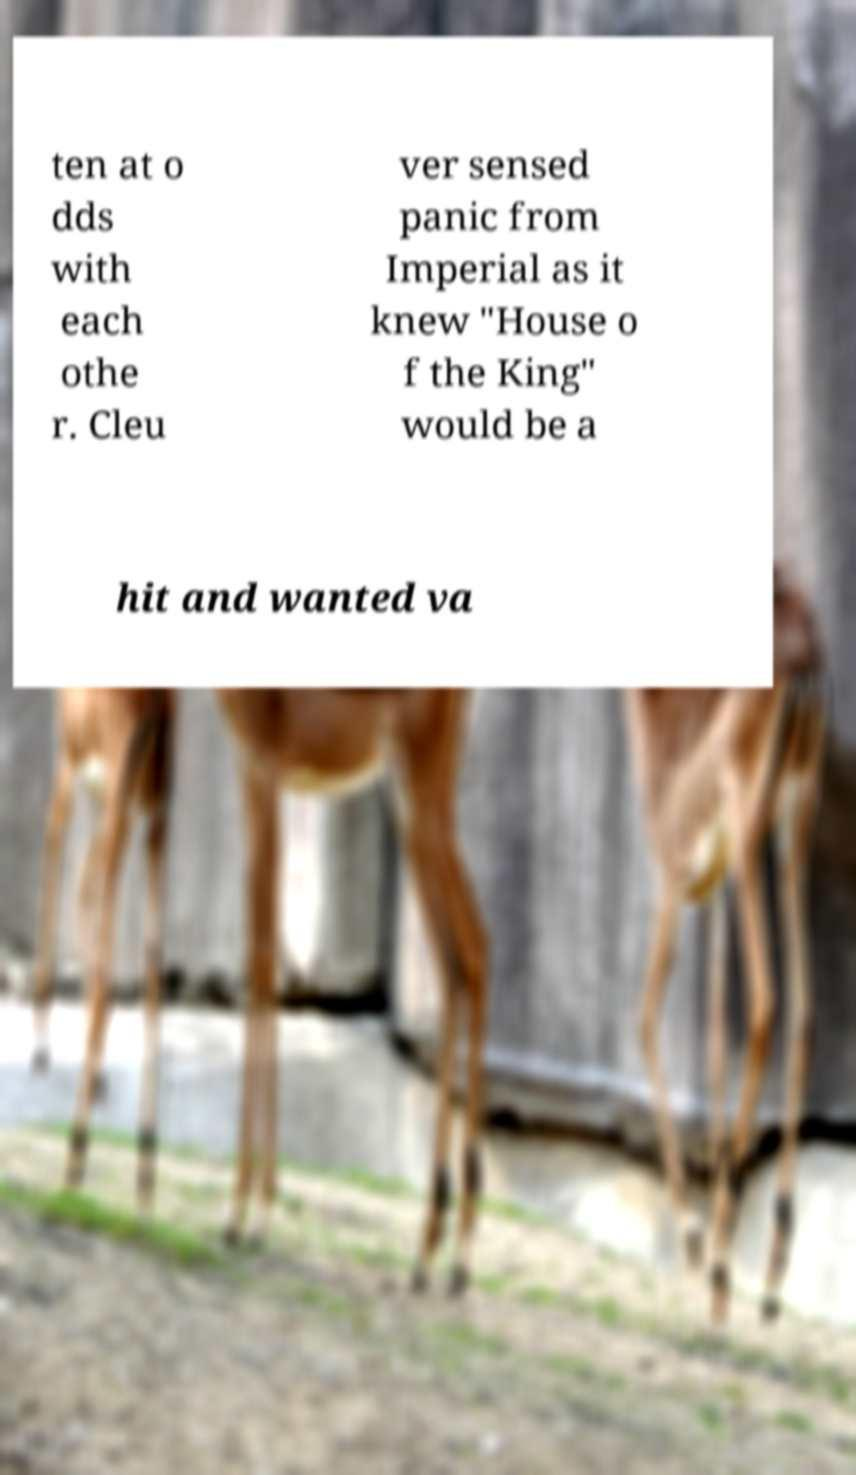Could you assist in decoding the text presented in this image and type it out clearly? ten at o dds with each othe r. Cleu ver sensed panic from Imperial as it knew "House o f the King" would be a hit and wanted va 